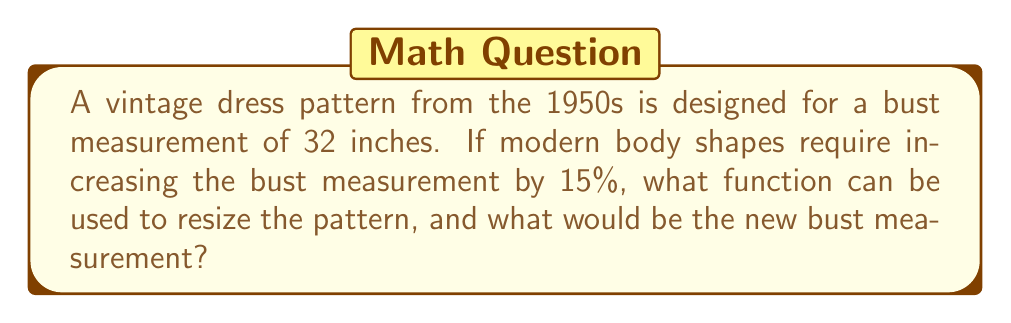Give your solution to this math problem. Let's approach this step-by-step:

1) First, we need to identify the transformation. This is a dilation (scaling) transformation.

2) The general form of a dilation transformation is:
   $f(x) = kx$, where $k$ is the scale factor

3) To increase a measurement by 15%, we multiply by 1.15:
   $k = 1 + 0.15 = 1.15$

4) So, our transformation function is:
   $f(x) = 1.15x$

5) To find the new bust measurement, we apply this function to the original measurement:
   $f(32) = 1.15 * 32 = 36.8$

Therefore, the function to resize the pattern is $f(x) = 1.15x$, and the new bust measurement would be 36.8 inches.
Answer: $f(x) = 1.15x$; 36.8 inches 